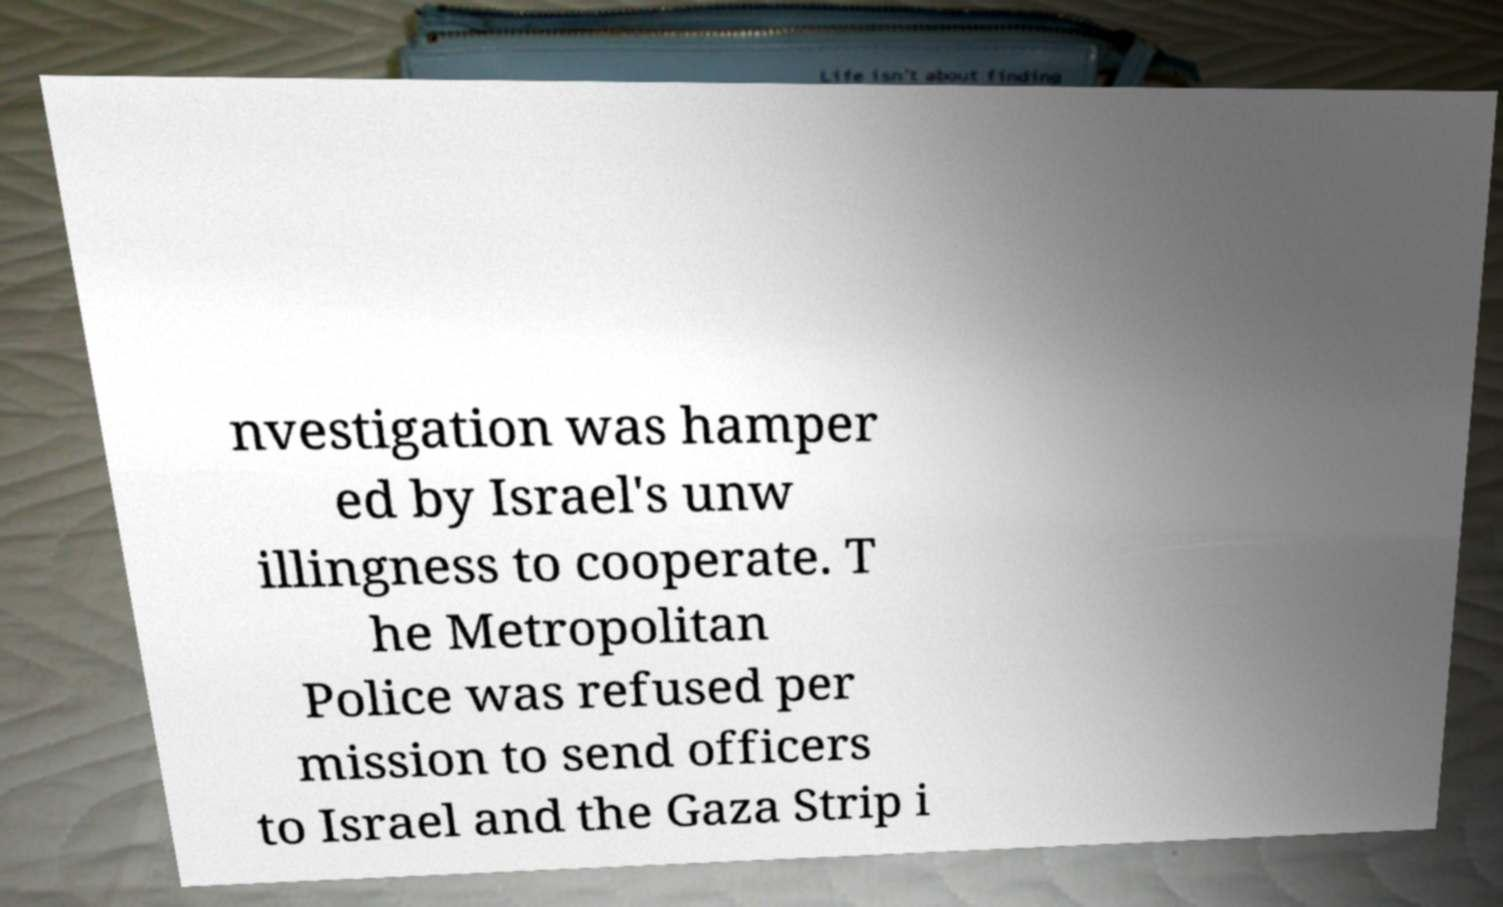Please read and relay the text visible in this image. What does it say? nvestigation was hamper ed by Israel's unw illingness to cooperate. T he Metropolitan Police was refused per mission to send officers to Israel and the Gaza Strip i 